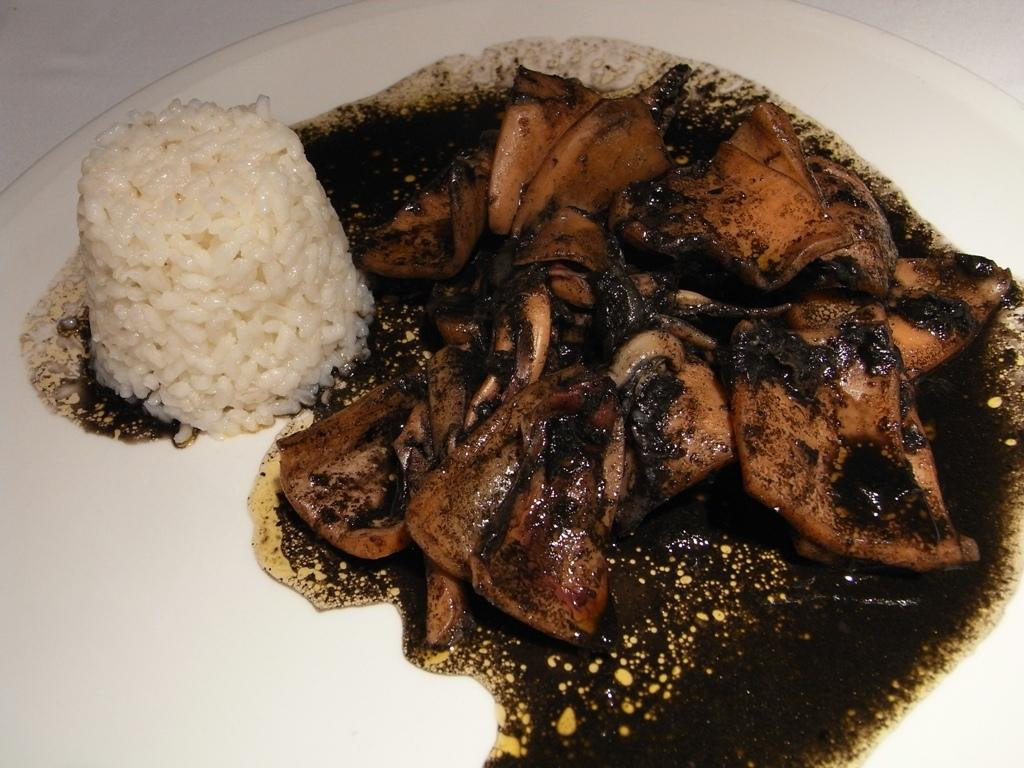What type of food items can be seen in the image? The image contains food items, but the specific type of food cannot be determined from the provided facts. How are the food items arranged or presented in the image? The food items are in a white plate. What type of grain is being harvested by the slaves in the image? There is no reference to any grain, force, or slave in the image, so it is not possible to answer that question. 